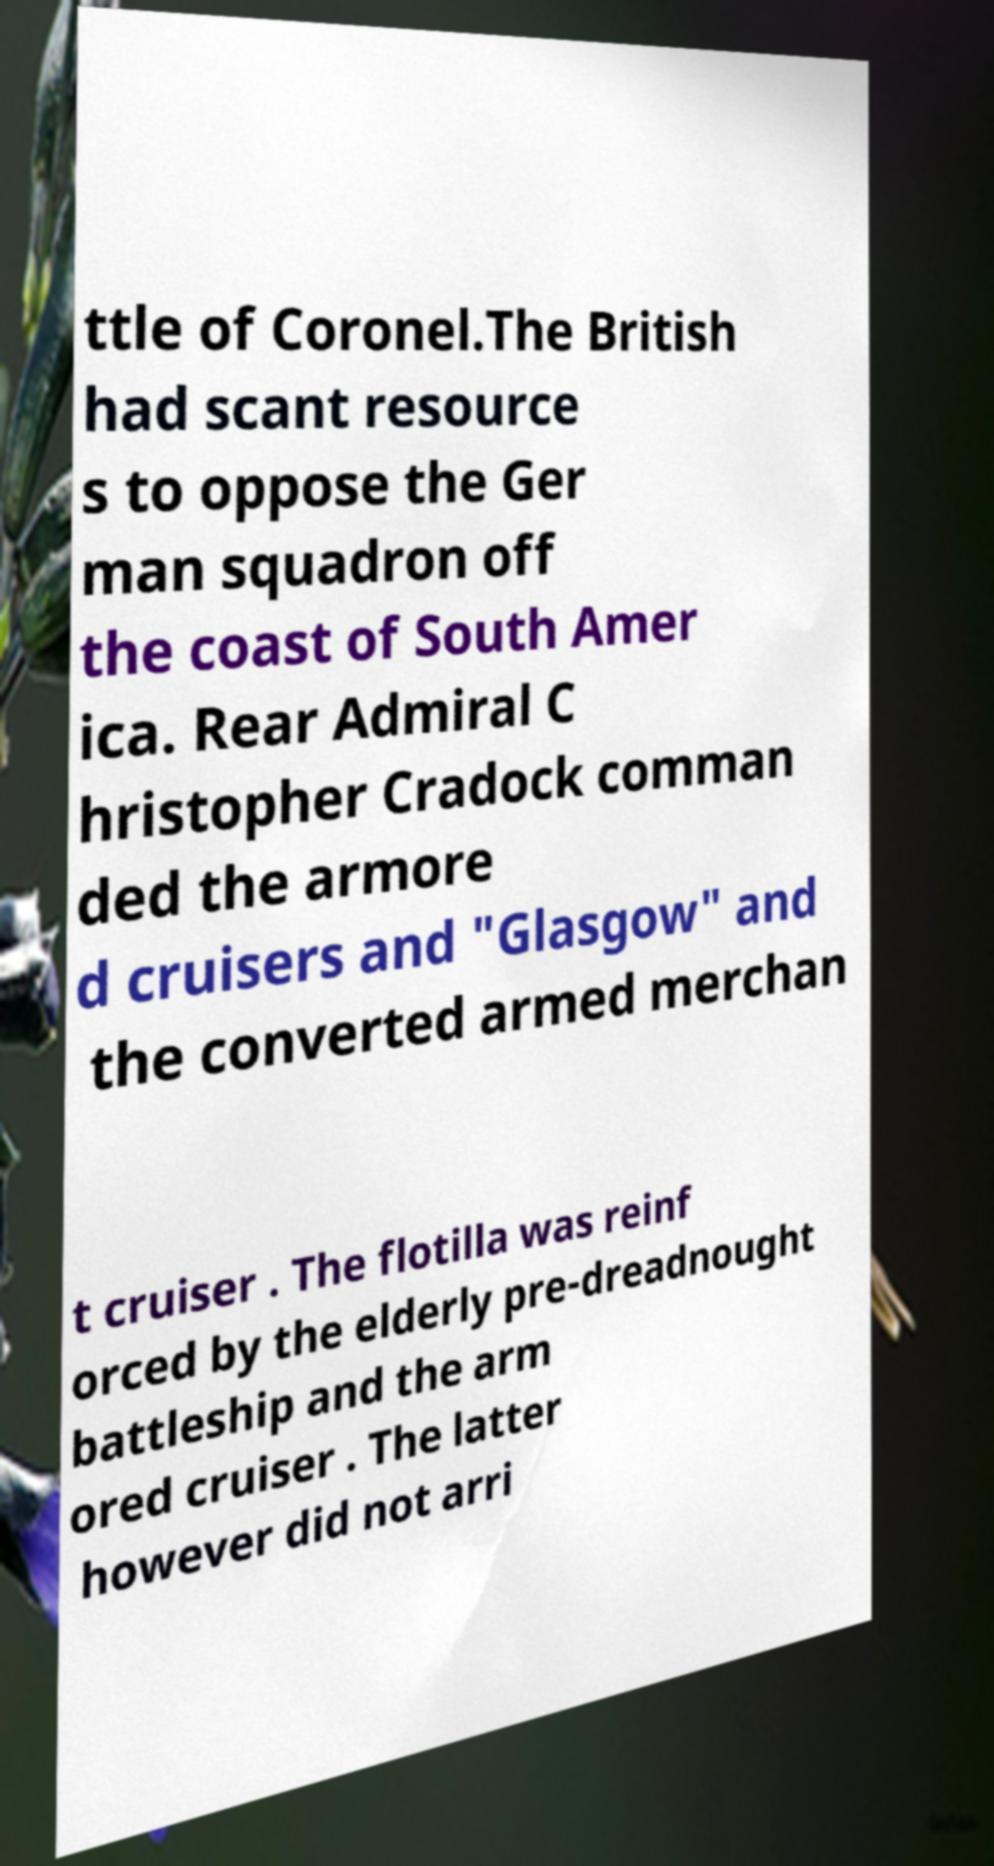There's text embedded in this image that I need extracted. Can you transcribe it verbatim? ttle of Coronel.The British had scant resource s to oppose the Ger man squadron off the coast of South Amer ica. Rear Admiral C hristopher Cradock comman ded the armore d cruisers and "Glasgow" and the converted armed merchan t cruiser . The flotilla was reinf orced by the elderly pre-dreadnought battleship and the arm ored cruiser . The latter however did not arri 